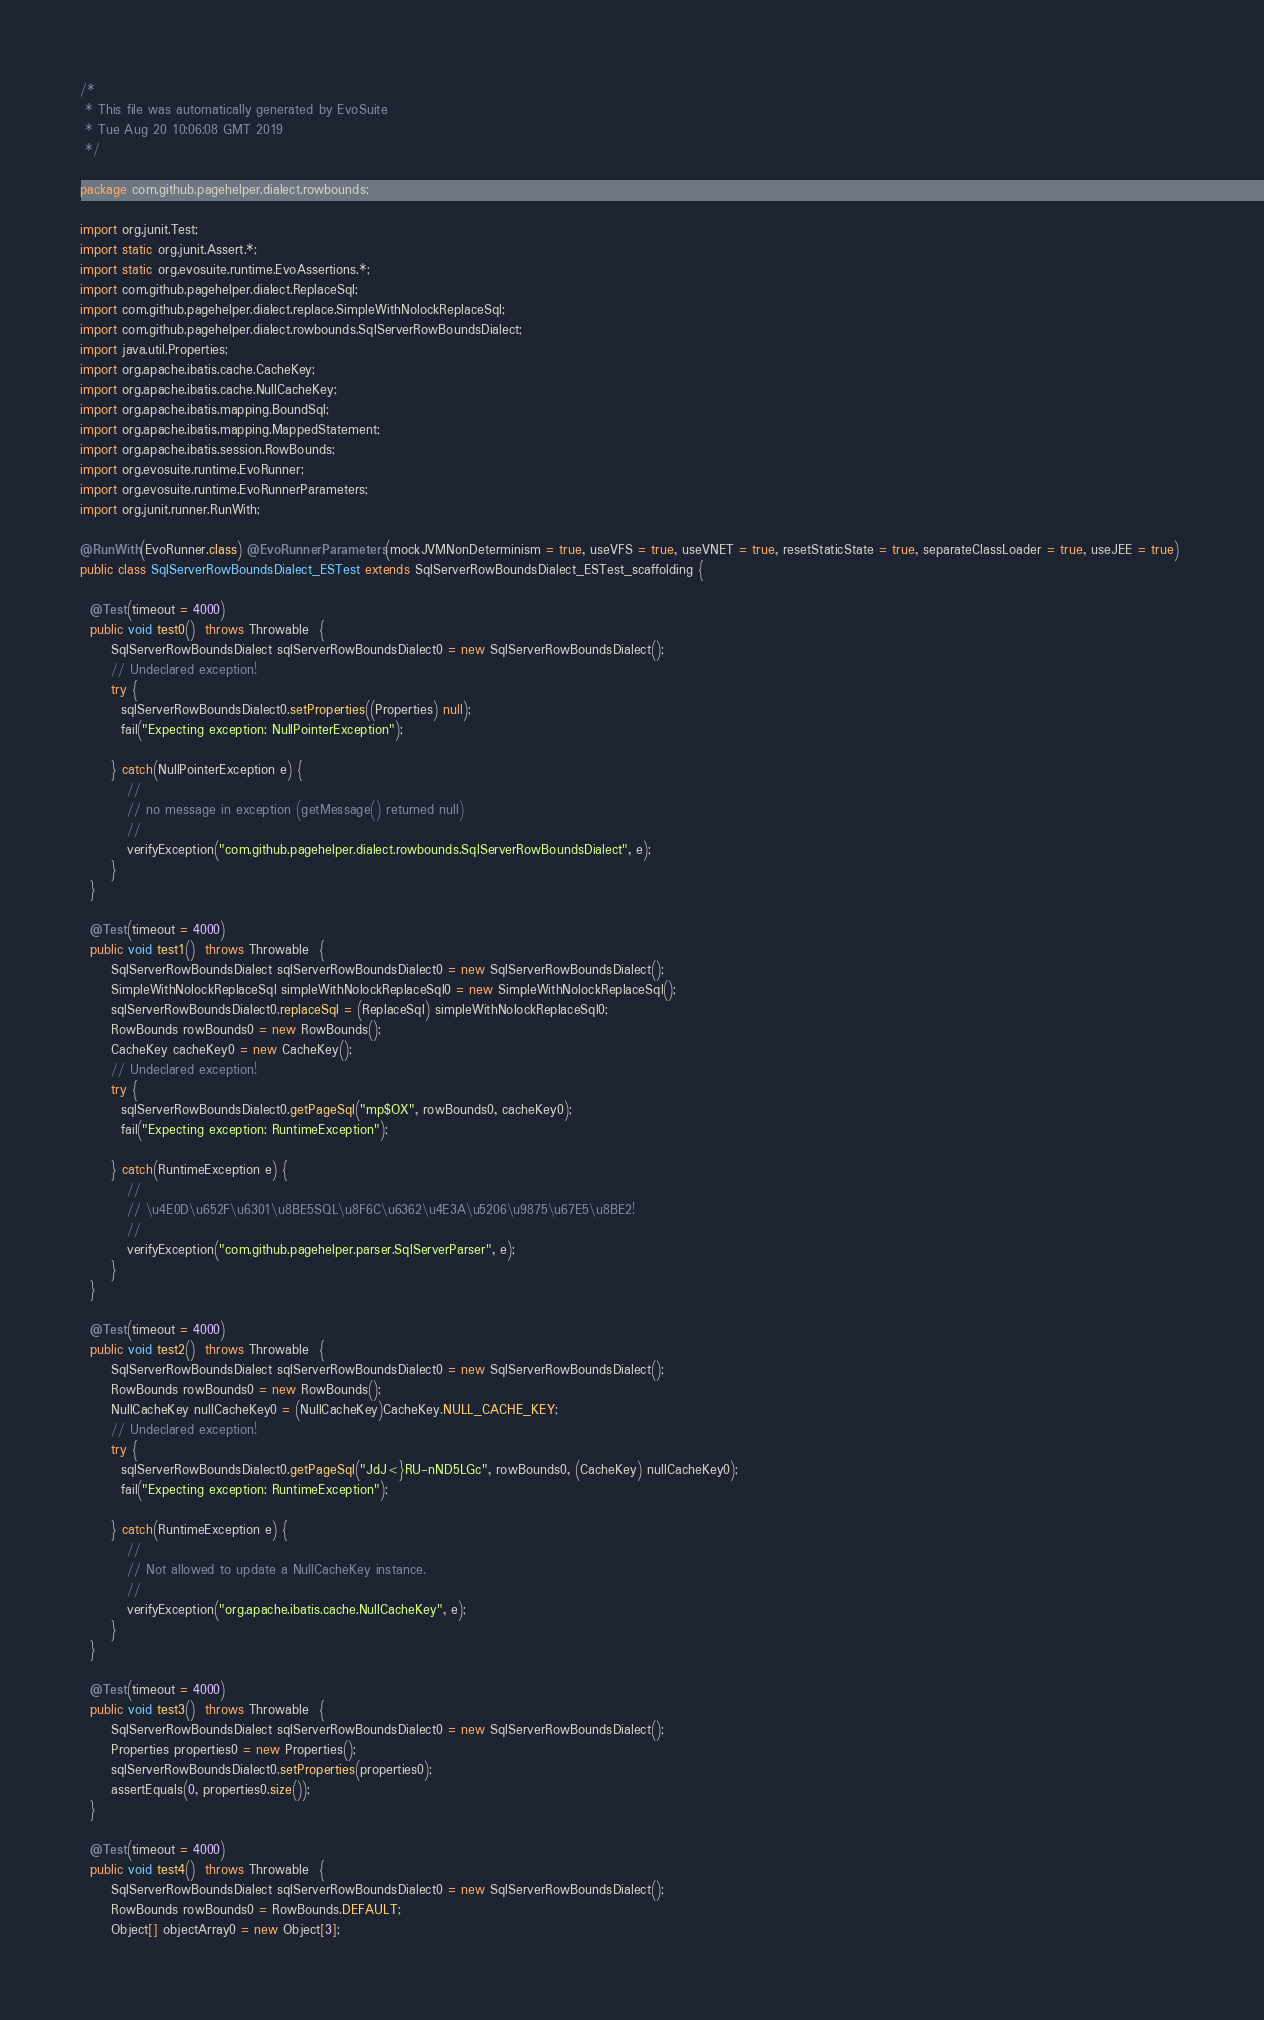Convert code to text. <code><loc_0><loc_0><loc_500><loc_500><_Java_>/*
 * This file was automatically generated by EvoSuite
 * Tue Aug 20 10:06:08 GMT 2019
 */

package com.github.pagehelper.dialect.rowbounds;

import org.junit.Test;
import static org.junit.Assert.*;
import static org.evosuite.runtime.EvoAssertions.*;
import com.github.pagehelper.dialect.ReplaceSql;
import com.github.pagehelper.dialect.replace.SimpleWithNolockReplaceSql;
import com.github.pagehelper.dialect.rowbounds.SqlServerRowBoundsDialect;
import java.util.Properties;
import org.apache.ibatis.cache.CacheKey;
import org.apache.ibatis.cache.NullCacheKey;
import org.apache.ibatis.mapping.BoundSql;
import org.apache.ibatis.mapping.MappedStatement;
import org.apache.ibatis.session.RowBounds;
import org.evosuite.runtime.EvoRunner;
import org.evosuite.runtime.EvoRunnerParameters;
import org.junit.runner.RunWith;

@RunWith(EvoRunner.class) @EvoRunnerParameters(mockJVMNonDeterminism = true, useVFS = true, useVNET = true, resetStaticState = true, separateClassLoader = true, useJEE = true) 
public class SqlServerRowBoundsDialect_ESTest extends SqlServerRowBoundsDialect_ESTest_scaffolding {

  @Test(timeout = 4000)
  public void test0()  throws Throwable  {
      SqlServerRowBoundsDialect sqlServerRowBoundsDialect0 = new SqlServerRowBoundsDialect();
      // Undeclared exception!
      try { 
        sqlServerRowBoundsDialect0.setProperties((Properties) null);
        fail("Expecting exception: NullPointerException");
      
      } catch(NullPointerException e) {
         //
         // no message in exception (getMessage() returned null)
         //
         verifyException("com.github.pagehelper.dialect.rowbounds.SqlServerRowBoundsDialect", e);
      }
  }

  @Test(timeout = 4000)
  public void test1()  throws Throwable  {
      SqlServerRowBoundsDialect sqlServerRowBoundsDialect0 = new SqlServerRowBoundsDialect();
      SimpleWithNolockReplaceSql simpleWithNolockReplaceSql0 = new SimpleWithNolockReplaceSql();
      sqlServerRowBoundsDialect0.replaceSql = (ReplaceSql) simpleWithNolockReplaceSql0;
      RowBounds rowBounds0 = new RowBounds();
      CacheKey cacheKey0 = new CacheKey();
      // Undeclared exception!
      try { 
        sqlServerRowBoundsDialect0.getPageSql("mp$OX", rowBounds0, cacheKey0);
        fail("Expecting exception: RuntimeException");
      
      } catch(RuntimeException e) {
         //
         // \u4E0D\u652F\u6301\u8BE5SQL\u8F6C\u6362\u4E3A\u5206\u9875\u67E5\u8BE2!
         //
         verifyException("com.github.pagehelper.parser.SqlServerParser", e);
      }
  }

  @Test(timeout = 4000)
  public void test2()  throws Throwable  {
      SqlServerRowBoundsDialect sqlServerRowBoundsDialect0 = new SqlServerRowBoundsDialect();
      RowBounds rowBounds0 = new RowBounds();
      NullCacheKey nullCacheKey0 = (NullCacheKey)CacheKey.NULL_CACHE_KEY;
      // Undeclared exception!
      try { 
        sqlServerRowBoundsDialect0.getPageSql("JdJ<}RU-nND5LGc", rowBounds0, (CacheKey) nullCacheKey0);
        fail("Expecting exception: RuntimeException");
      
      } catch(RuntimeException e) {
         //
         // Not allowed to update a NullCacheKey instance.
         //
         verifyException("org.apache.ibatis.cache.NullCacheKey", e);
      }
  }

  @Test(timeout = 4000)
  public void test3()  throws Throwable  {
      SqlServerRowBoundsDialect sqlServerRowBoundsDialect0 = new SqlServerRowBoundsDialect();
      Properties properties0 = new Properties();
      sqlServerRowBoundsDialect0.setProperties(properties0);
      assertEquals(0, properties0.size());
  }

  @Test(timeout = 4000)
  public void test4()  throws Throwable  {
      SqlServerRowBoundsDialect sqlServerRowBoundsDialect0 = new SqlServerRowBoundsDialect();
      RowBounds rowBounds0 = RowBounds.DEFAULT;
      Object[] objectArray0 = new Object[3];</code> 